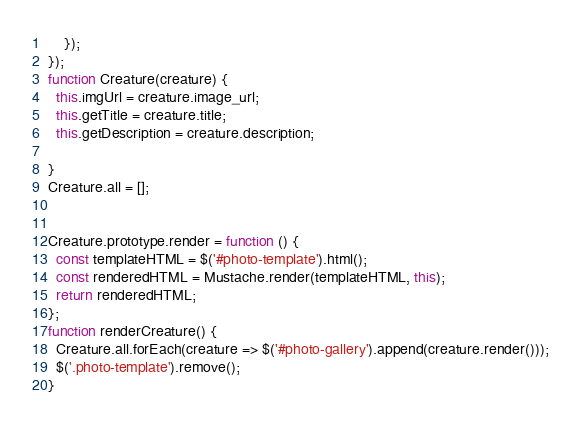Convert code to text. <code><loc_0><loc_0><loc_500><loc_500><_JavaScript_>    });
});
function Creature(creature) {
  this.imgUrl = creature.image_url;
  this.getTitle = creature.title;
  this.getDescription = creature.description;
  
}
Creature.all = [];


Creature.prototype.render = function () {
  const templateHTML = $('#photo-template').html();
  const renderedHTML = Mustache.render(templateHTML, this);
  return renderedHTML;
};
function renderCreature() {
  Creature.all.forEach(creature => $('#photo-gallery').append(creature.render()));
  $('.photo-template').remove();
}

</code> 